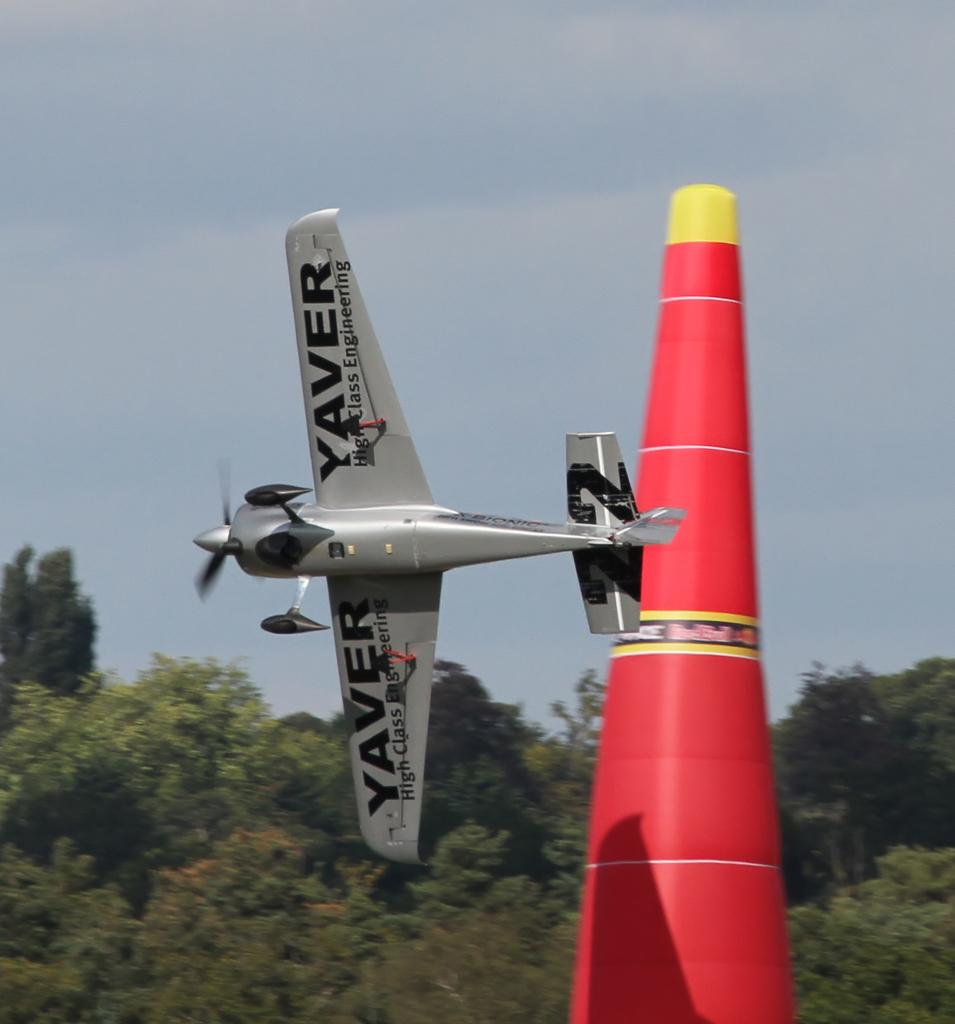<image>
Provide a brief description of the given image. the plane advertising Yaver is flying close to the red cone 